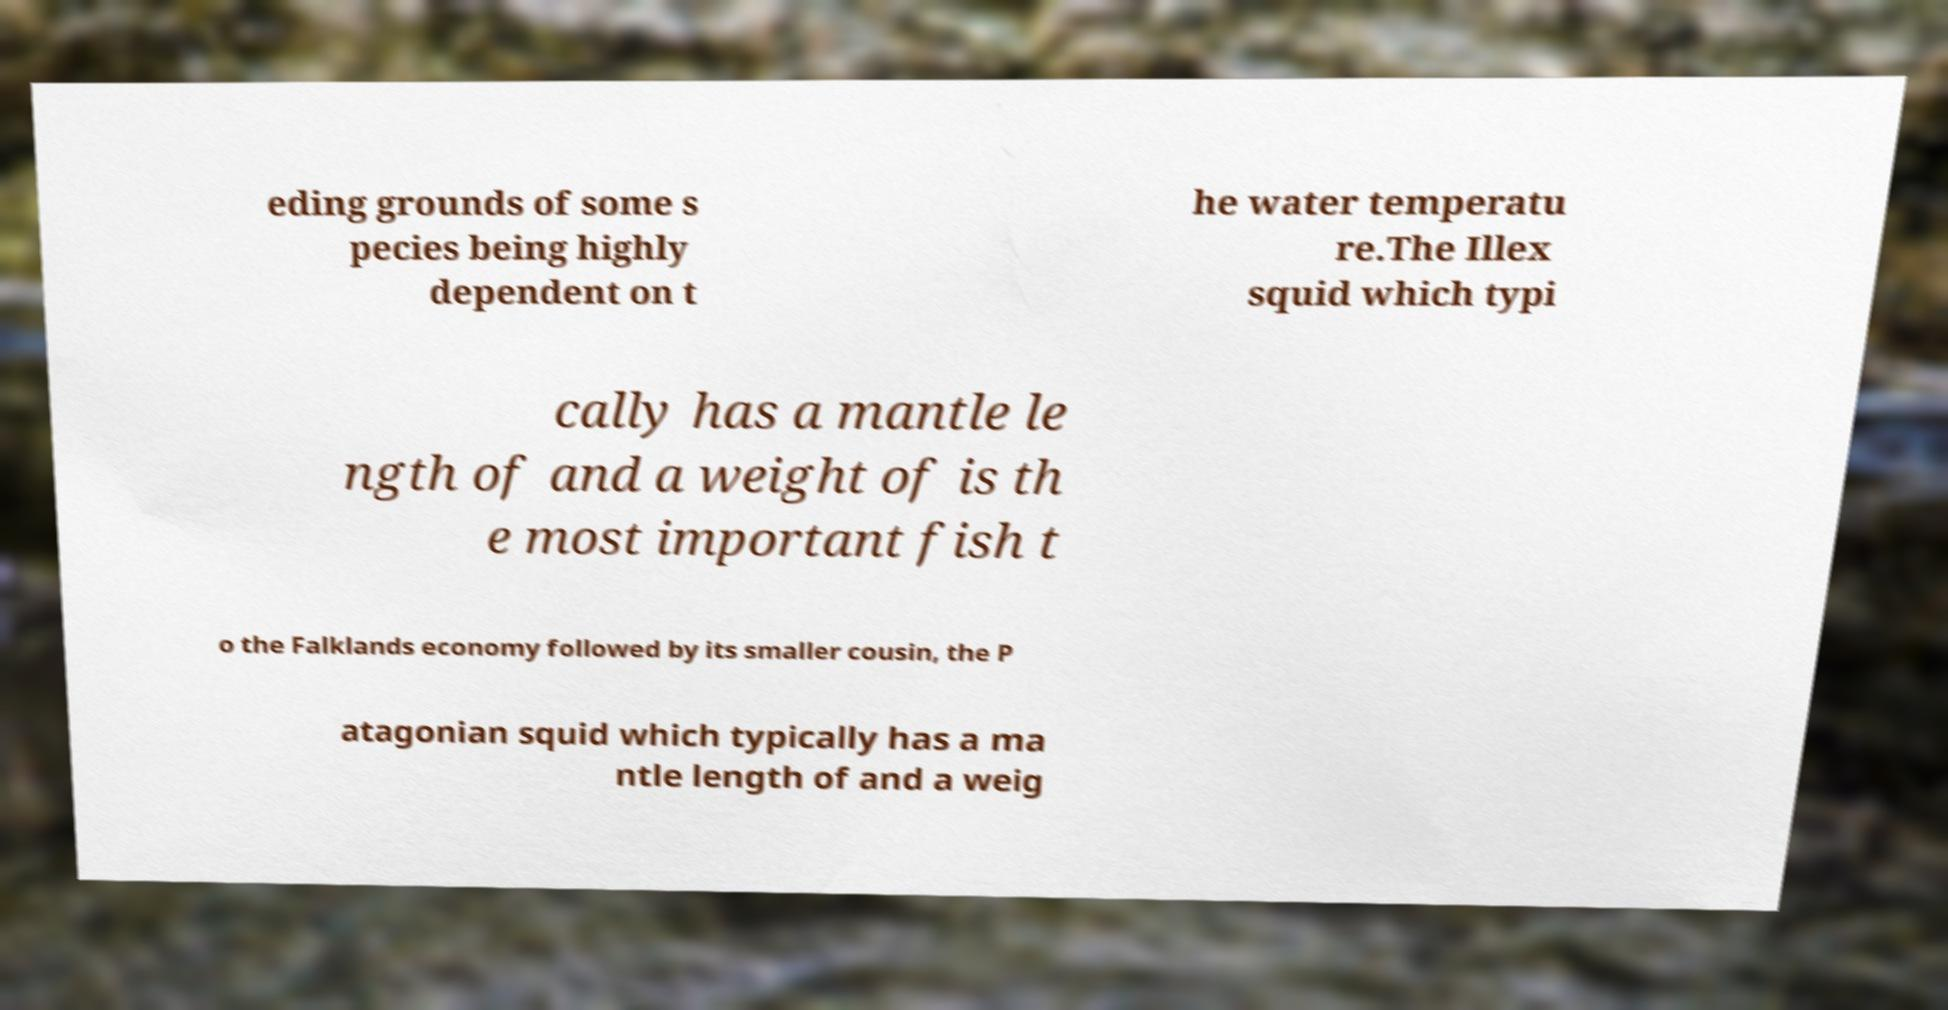Can you read and provide the text displayed in the image?This photo seems to have some interesting text. Can you extract and type it out for me? eding grounds of some s pecies being highly dependent on t he water temperatu re.The Illex squid which typi cally has a mantle le ngth of and a weight of is th e most important fish t o the Falklands economy followed by its smaller cousin, the P atagonian squid which typically has a ma ntle length of and a weig 